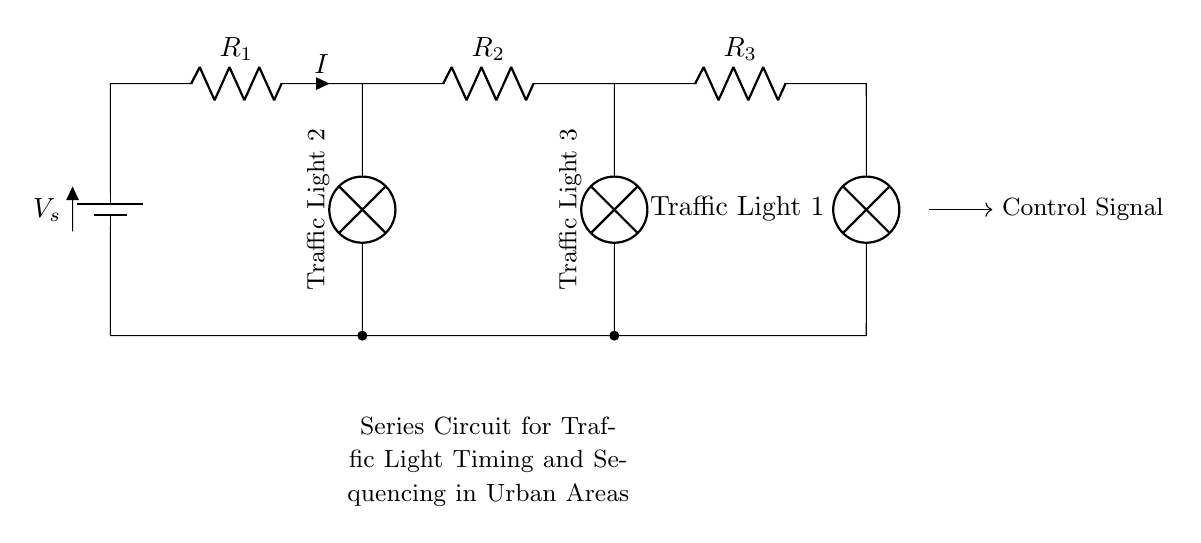What is the total number of resistors in the circuit? There are three resistors in the circuit, labeled R1, R2, and R3. Counting them yields a total of three.
Answer: three What is the role of the control signal in this circuit? The control signal is used to manage the operation and sequencing of the traffic lights. It indicates when each traffic light should change, facilitating traffic flow.
Answer: sequencing How many traffic lights are in this circuit? The circuit has three traffic lights, as indicated by the labels corresponding to Traffic Light 1, Traffic Light 2, and Traffic Light 3. Counting these gives a total of three lights.
Answer: three What happens to the current in this series circuit? In a series circuit, the current remains the same throughout all components. Therefore, the current does not change as it passes through each resistor and traffic light.
Answer: same Which component directly indicates traffic light 1? Traffic Light 1 is directly connected to the last position in the circuit and is labeled as such in the diagram.
Answer: lamp What is the relationship between the resistance values in a series circuit? The total resistance in a series circuit is the sum of the individual resistances, which means the overall resistance increases with each added resistor in this circuit.
Answer: sum What type of circuit is indicated in this diagram? The diagram represents a series circuit where components are connected end-to-end, causing the same current to flow through all components.
Answer: series 